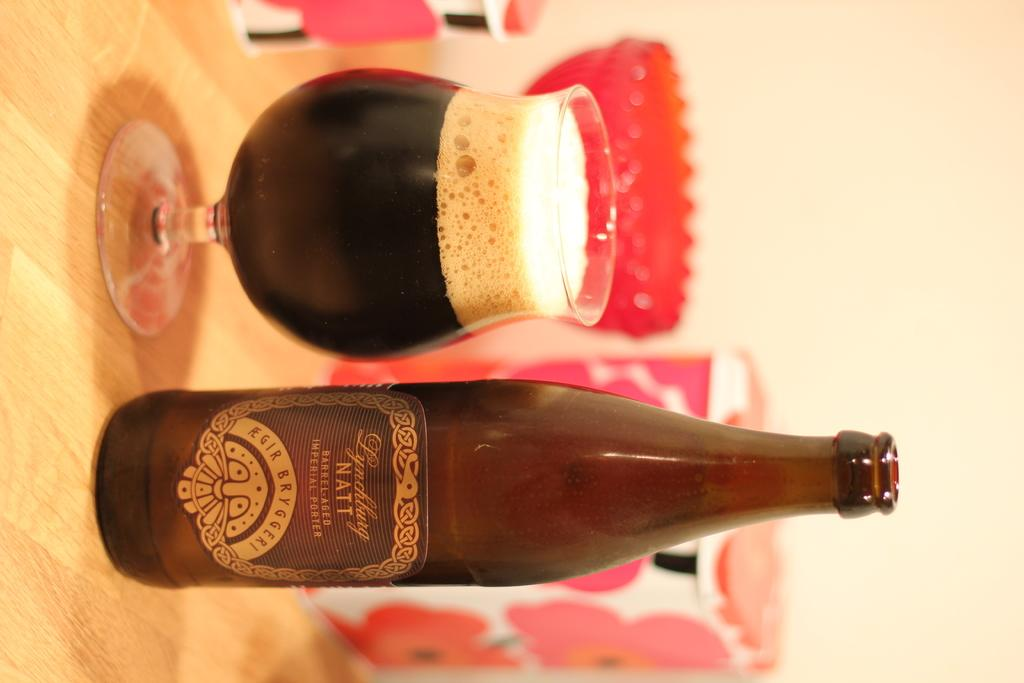What type of table is in the image? There is a wooden table in the image. What is on the wooden table? There is a wine bottle and a glass of wine on the table. How many trees are needed to make the wooden table in the image? There is no information about the number of trees needed to make the wooden table in the image, nor is there any indication of the table's construction. 